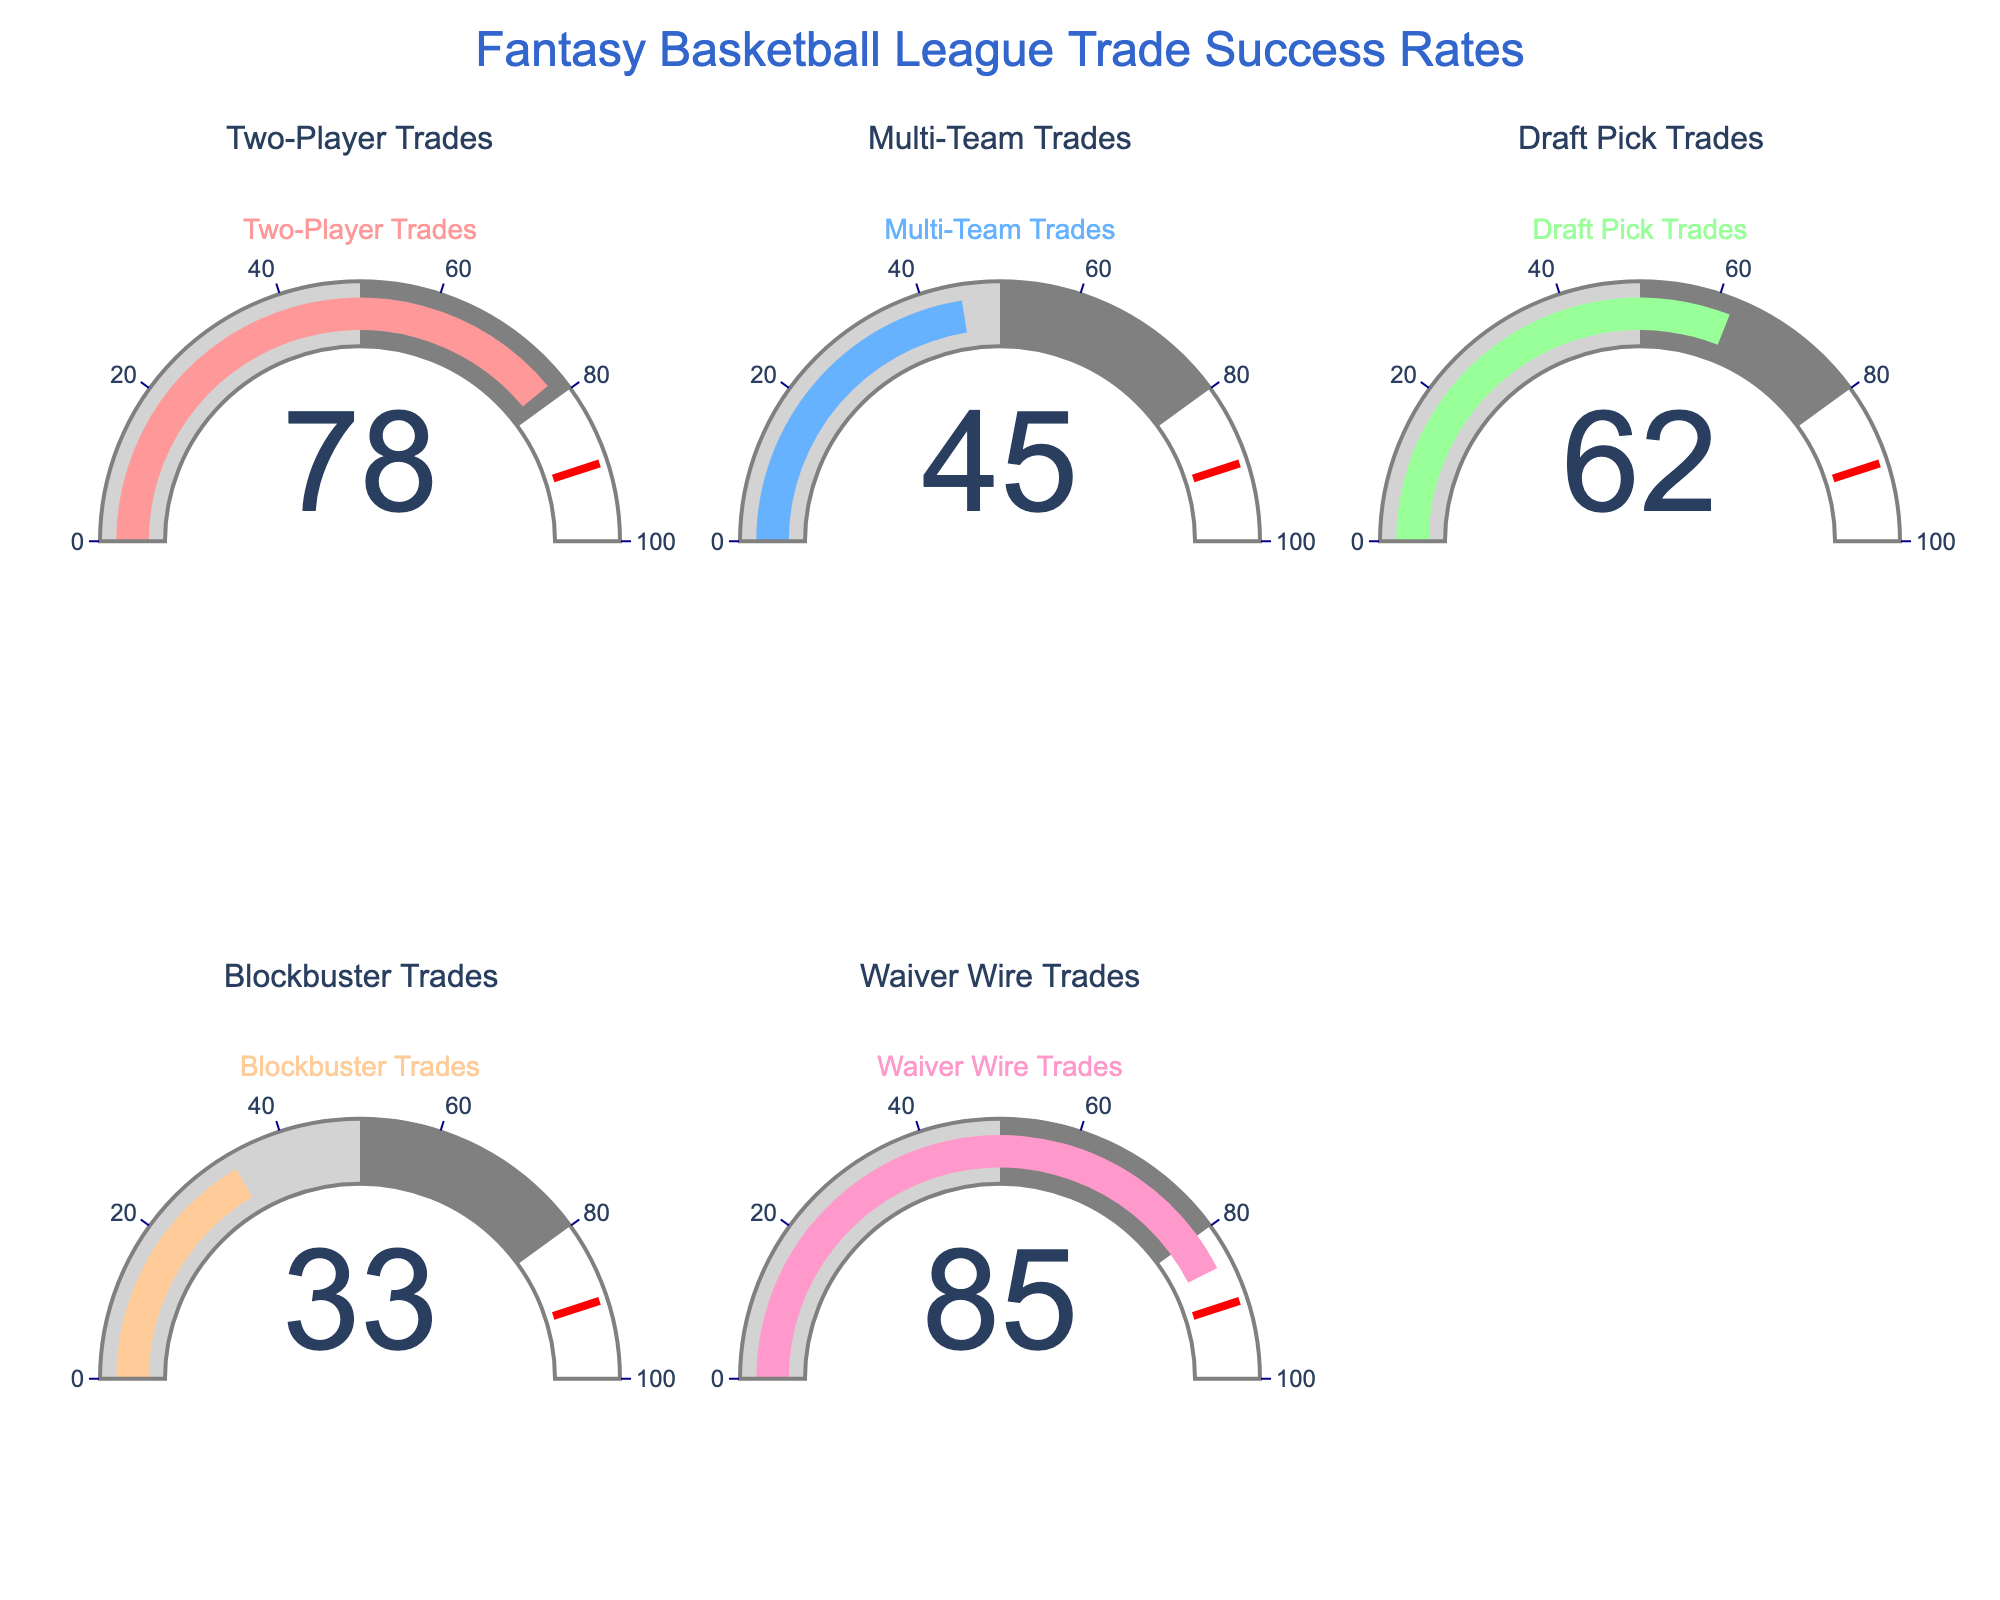What's the title of the figure? The title of the figure is typically displayed at the top and provides an overview of the chart's content. In this case, the title is "Fantasy Basketball League Trade Success Rates".
Answer: Fantasy Basketball League Trade Success Rates What's the highest percentage shown on the gauges? Look at all the gauge values and identify the highest numeric value displayed. The gauge with the highest percentage shows 85%.
Answer: 85% Which type of trade has the lowest success percentage? Review each gauge to find the type of trade with the smallest numerical value. The "Blockbuster Trades" gauge shows the lowest percentage, which is 33%.
Answer: Blockbuster Trades What is the average success percentage across all trade types? Add all the percentages and divide by the number of different trade types. The sum of the percentages is 78 + 45 + 62 + 33 + 85 = 303. There are 5 trade types, so the average is 303 / 5 = 60.6%.
Answer: 60.6% By how much does the success percentage of Draft Pick Trades exceed Blockbuster Trades? Subtract the success percentage of Blockbuster Trades from that of Draft Pick Trades. The difference is 62% - 33% = 29%.
Answer: 29% How many different trade types are displayed in the figure? Count the total number of gauges displayed. There are 5 gauges, each representing a different type of trade.
Answer: 5 Is the success percentage of Waiver Wire Trades higher or lower than Two-Player Trades? Compare the success percentages of Waiver Wire Trades (85%) and Two-Player Trades (78%). Waiver Wire Trades have a higher percentage.
Answer: Higher Which trade type has a success rate of more than 50% but less than 70%? Identify the gauge(s) displaying a value between 50% and 70%. The "Draft Pick Trades" gauge shows 62%, which falls within this range.
Answer: Draft Pick Trades If we combine the success percentages of Multi-Team Trades and Two-Player Trades, what would be the total percentage? Add the success percentages of Multi-Team Trades and Two-Player Trades. The total is 45% + 78% = 123%.
Answer: 123% Is there any trade type with a success percentage close to the threshold value of 90%? Examine each gauge's percentage value and note if any are near 90%. The threshold value for gauges is marked at 90%, but none of the trade types reach this value.
Answer: No 